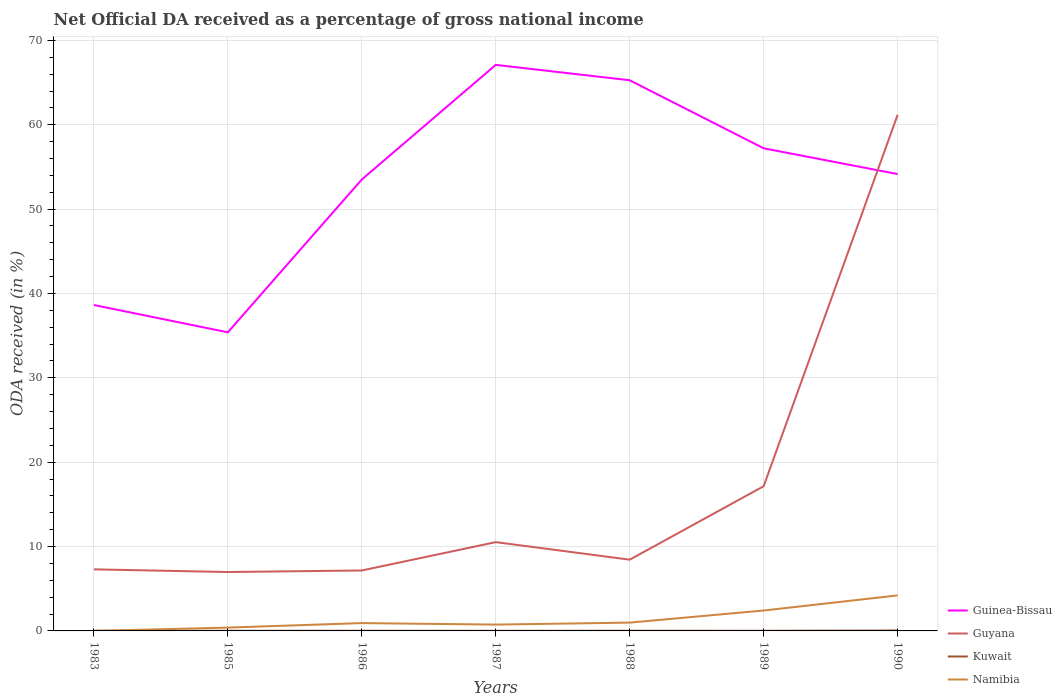Is the number of lines equal to the number of legend labels?
Offer a very short reply. Yes. Across all years, what is the maximum net official DA received in Guinea-Bissau?
Your response must be concise. 35.4. What is the total net official DA received in Namibia in the graph?
Your response must be concise. -3.46. What is the difference between the highest and the second highest net official DA received in Namibia?
Provide a succinct answer. 4.21. What is the difference between the highest and the lowest net official DA received in Kuwait?
Your answer should be compact. 1. What is the difference between two consecutive major ticks on the Y-axis?
Your answer should be compact. 10. Does the graph contain any zero values?
Offer a very short reply. No. Does the graph contain grids?
Give a very brief answer. Yes. How many legend labels are there?
Offer a very short reply. 4. How are the legend labels stacked?
Ensure brevity in your answer.  Vertical. What is the title of the graph?
Make the answer very short. Net Official DA received as a percentage of gross national income. Does "Finland" appear as one of the legend labels in the graph?
Your answer should be compact. No. What is the label or title of the Y-axis?
Make the answer very short. ODA received (in %). What is the ODA received (in %) in Guinea-Bissau in 1983?
Give a very brief answer. 38.63. What is the ODA received (in %) of Guyana in 1983?
Provide a succinct answer. 7.3. What is the ODA received (in %) of Kuwait in 1983?
Give a very brief answer. 0.02. What is the ODA received (in %) of Namibia in 1983?
Make the answer very short. 0. What is the ODA received (in %) in Guinea-Bissau in 1985?
Provide a short and direct response. 35.4. What is the ODA received (in %) in Guyana in 1985?
Provide a short and direct response. 6.98. What is the ODA received (in %) of Kuwait in 1985?
Offer a terse response. 0.02. What is the ODA received (in %) in Namibia in 1985?
Make the answer very short. 0.4. What is the ODA received (in %) of Guinea-Bissau in 1986?
Give a very brief answer. 53.51. What is the ODA received (in %) of Guyana in 1986?
Provide a succinct answer. 7.17. What is the ODA received (in %) in Kuwait in 1986?
Offer a very short reply. 0.02. What is the ODA received (in %) of Namibia in 1986?
Provide a succinct answer. 0.93. What is the ODA received (in %) of Guinea-Bissau in 1987?
Offer a terse response. 67.1. What is the ODA received (in %) in Guyana in 1987?
Keep it short and to the point. 10.52. What is the ODA received (in %) of Kuwait in 1987?
Offer a terse response. 0.01. What is the ODA received (in %) in Namibia in 1987?
Offer a terse response. 0.75. What is the ODA received (in %) of Guinea-Bissau in 1988?
Provide a succinct answer. 65.27. What is the ODA received (in %) in Guyana in 1988?
Make the answer very short. 8.45. What is the ODA received (in %) in Kuwait in 1988?
Give a very brief answer. 0.02. What is the ODA received (in %) of Namibia in 1988?
Provide a short and direct response. 0.99. What is the ODA received (in %) of Guinea-Bissau in 1989?
Offer a terse response. 57.21. What is the ODA received (in %) in Guyana in 1989?
Give a very brief answer. 17.15. What is the ODA received (in %) of Kuwait in 1989?
Offer a terse response. 0.01. What is the ODA received (in %) of Namibia in 1989?
Your answer should be compact. 2.42. What is the ODA received (in %) in Guinea-Bissau in 1990?
Give a very brief answer. 54.15. What is the ODA received (in %) of Guyana in 1990?
Your answer should be very brief. 61.17. What is the ODA received (in %) in Kuwait in 1990?
Your answer should be very brief. 0.05. What is the ODA received (in %) in Namibia in 1990?
Provide a succinct answer. 4.21. Across all years, what is the maximum ODA received (in %) of Guinea-Bissau?
Keep it short and to the point. 67.1. Across all years, what is the maximum ODA received (in %) of Guyana?
Your answer should be compact. 61.17. Across all years, what is the maximum ODA received (in %) in Kuwait?
Make the answer very short. 0.05. Across all years, what is the maximum ODA received (in %) in Namibia?
Give a very brief answer. 4.21. Across all years, what is the minimum ODA received (in %) in Guinea-Bissau?
Keep it short and to the point. 35.4. Across all years, what is the minimum ODA received (in %) in Guyana?
Make the answer very short. 6.98. Across all years, what is the minimum ODA received (in %) of Kuwait?
Make the answer very short. 0.01. Across all years, what is the minimum ODA received (in %) of Namibia?
Keep it short and to the point. 0. What is the total ODA received (in %) in Guinea-Bissau in the graph?
Provide a succinct answer. 371.27. What is the total ODA received (in %) in Guyana in the graph?
Ensure brevity in your answer.  118.74. What is the total ODA received (in %) of Kuwait in the graph?
Provide a short and direct response. 0.15. What is the total ODA received (in %) of Namibia in the graph?
Your response must be concise. 9.69. What is the difference between the ODA received (in %) in Guinea-Bissau in 1983 and that in 1985?
Offer a very short reply. 3.23. What is the difference between the ODA received (in %) in Guyana in 1983 and that in 1985?
Make the answer very short. 0.32. What is the difference between the ODA received (in %) of Kuwait in 1983 and that in 1985?
Keep it short and to the point. 0. What is the difference between the ODA received (in %) in Namibia in 1983 and that in 1985?
Provide a succinct answer. -0.39. What is the difference between the ODA received (in %) of Guinea-Bissau in 1983 and that in 1986?
Offer a very short reply. -14.88. What is the difference between the ODA received (in %) of Guyana in 1983 and that in 1986?
Make the answer very short. 0.13. What is the difference between the ODA received (in %) of Namibia in 1983 and that in 1986?
Ensure brevity in your answer.  -0.93. What is the difference between the ODA received (in %) in Guinea-Bissau in 1983 and that in 1987?
Offer a very short reply. -28.47. What is the difference between the ODA received (in %) of Guyana in 1983 and that in 1987?
Your answer should be compact. -3.23. What is the difference between the ODA received (in %) of Kuwait in 1983 and that in 1987?
Offer a very short reply. 0.01. What is the difference between the ODA received (in %) of Namibia in 1983 and that in 1987?
Your response must be concise. -0.75. What is the difference between the ODA received (in %) in Guinea-Bissau in 1983 and that in 1988?
Give a very brief answer. -26.64. What is the difference between the ODA received (in %) of Guyana in 1983 and that in 1988?
Give a very brief answer. -1.15. What is the difference between the ODA received (in %) in Kuwait in 1983 and that in 1988?
Ensure brevity in your answer.  -0. What is the difference between the ODA received (in %) in Namibia in 1983 and that in 1988?
Ensure brevity in your answer.  -0.98. What is the difference between the ODA received (in %) in Guinea-Bissau in 1983 and that in 1989?
Offer a very short reply. -18.58. What is the difference between the ODA received (in %) of Guyana in 1983 and that in 1989?
Provide a short and direct response. -9.85. What is the difference between the ODA received (in %) in Kuwait in 1983 and that in 1989?
Offer a terse response. 0.01. What is the difference between the ODA received (in %) in Namibia in 1983 and that in 1989?
Provide a succinct answer. -2.42. What is the difference between the ODA received (in %) in Guinea-Bissau in 1983 and that in 1990?
Offer a terse response. -15.52. What is the difference between the ODA received (in %) of Guyana in 1983 and that in 1990?
Offer a very short reply. -53.87. What is the difference between the ODA received (in %) of Kuwait in 1983 and that in 1990?
Your response must be concise. -0.03. What is the difference between the ODA received (in %) of Namibia in 1983 and that in 1990?
Ensure brevity in your answer.  -4.21. What is the difference between the ODA received (in %) in Guinea-Bissau in 1985 and that in 1986?
Provide a succinct answer. -18.12. What is the difference between the ODA received (in %) in Guyana in 1985 and that in 1986?
Your answer should be compact. -0.18. What is the difference between the ODA received (in %) of Kuwait in 1985 and that in 1986?
Your answer should be compact. -0. What is the difference between the ODA received (in %) of Namibia in 1985 and that in 1986?
Offer a terse response. -0.53. What is the difference between the ODA received (in %) in Guinea-Bissau in 1985 and that in 1987?
Make the answer very short. -31.7. What is the difference between the ODA received (in %) of Guyana in 1985 and that in 1987?
Ensure brevity in your answer.  -3.54. What is the difference between the ODA received (in %) of Kuwait in 1985 and that in 1987?
Your answer should be very brief. 0. What is the difference between the ODA received (in %) of Namibia in 1985 and that in 1987?
Provide a succinct answer. -0.35. What is the difference between the ODA received (in %) in Guinea-Bissau in 1985 and that in 1988?
Keep it short and to the point. -29.88. What is the difference between the ODA received (in %) of Guyana in 1985 and that in 1988?
Your response must be concise. -1.46. What is the difference between the ODA received (in %) in Kuwait in 1985 and that in 1988?
Make the answer very short. -0.01. What is the difference between the ODA received (in %) in Namibia in 1985 and that in 1988?
Your answer should be very brief. -0.59. What is the difference between the ODA received (in %) of Guinea-Bissau in 1985 and that in 1989?
Your answer should be compact. -21.81. What is the difference between the ODA received (in %) of Guyana in 1985 and that in 1989?
Give a very brief answer. -10.17. What is the difference between the ODA received (in %) in Kuwait in 1985 and that in 1989?
Keep it short and to the point. 0. What is the difference between the ODA received (in %) of Namibia in 1985 and that in 1989?
Give a very brief answer. -2.02. What is the difference between the ODA received (in %) in Guinea-Bissau in 1985 and that in 1990?
Your answer should be very brief. -18.76. What is the difference between the ODA received (in %) in Guyana in 1985 and that in 1990?
Offer a very short reply. -54.19. What is the difference between the ODA received (in %) of Kuwait in 1985 and that in 1990?
Your response must be concise. -0.03. What is the difference between the ODA received (in %) of Namibia in 1985 and that in 1990?
Give a very brief answer. -3.81. What is the difference between the ODA received (in %) in Guinea-Bissau in 1986 and that in 1987?
Ensure brevity in your answer.  -13.58. What is the difference between the ODA received (in %) of Guyana in 1986 and that in 1987?
Your response must be concise. -3.36. What is the difference between the ODA received (in %) in Kuwait in 1986 and that in 1987?
Provide a succinct answer. 0.01. What is the difference between the ODA received (in %) in Namibia in 1986 and that in 1987?
Make the answer very short. 0.18. What is the difference between the ODA received (in %) in Guinea-Bissau in 1986 and that in 1988?
Your response must be concise. -11.76. What is the difference between the ODA received (in %) in Guyana in 1986 and that in 1988?
Give a very brief answer. -1.28. What is the difference between the ODA received (in %) of Kuwait in 1986 and that in 1988?
Provide a succinct answer. -0. What is the difference between the ODA received (in %) of Namibia in 1986 and that in 1988?
Your answer should be compact. -0.06. What is the difference between the ODA received (in %) of Guinea-Bissau in 1986 and that in 1989?
Give a very brief answer. -3.7. What is the difference between the ODA received (in %) of Guyana in 1986 and that in 1989?
Make the answer very short. -9.99. What is the difference between the ODA received (in %) of Kuwait in 1986 and that in 1989?
Your answer should be compact. 0. What is the difference between the ODA received (in %) in Namibia in 1986 and that in 1989?
Make the answer very short. -1.49. What is the difference between the ODA received (in %) in Guinea-Bissau in 1986 and that in 1990?
Your response must be concise. -0.64. What is the difference between the ODA received (in %) of Guyana in 1986 and that in 1990?
Keep it short and to the point. -54.01. What is the difference between the ODA received (in %) of Kuwait in 1986 and that in 1990?
Offer a very short reply. -0.03. What is the difference between the ODA received (in %) of Namibia in 1986 and that in 1990?
Your answer should be compact. -3.28. What is the difference between the ODA received (in %) of Guinea-Bissau in 1987 and that in 1988?
Make the answer very short. 1.82. What is the difference between the ODA received (in %) in Guyana in 1987 and that in 1988?
Keep it short and to the point. 2.08. What is the difference between the ODA received (in %) in Kuwait in 1987 and that in 1988?
Keep it short and to the point. -0.01. What is the difference between the ODA received (in %) of Namibia in 1987 and that in 1988?
Ensure brevity in your answer.  -0.24. What is the difference between the ODA received (in %) of Guinea-Bissau in 1987 and that in 1989?
Offer a terse response. 9.89. What is the difference between the ODA received (in %) of Guyana in 1987 and that in 1989?
Offer a terse response. -6.63. What is the difference between the ODA received (in %) of Kuwait in 1987 and that in 1989?
Offer a very short reply. -0. What is the difference between the ODA received (in %) of Namibia in 1987 and that in 1989?
Provide a succinct answer. -1.67. What is the difference between the ODA received (in %) of Guinea-Bissau in 1987 and that in 1990?
Your answer should be compact. 12.94. What is the difference between the ODA received (in %) in Guyana in 1987 and that in 1990?
Offer a very short reply. -50.65. What is the difference between the ODA received (in %) in Kuwait in 1987 and that in 1990?
Give a very brief answer. -0.04. What is the difference between the ODA received (in %) of Namibia in 1987 and that in 1990?
Your answer should be compact. -3.46. What is the difference between the ODA received (in %) in Guinea-Bissau in 1988 and that in 1989?
Provide a succinct answer. 8.06. What is the difference between the ODA received (in %) of Guyana in 1988 and that in 1989?
Your answer should be very brief. -8.71. What is the difference between the ODA received (in %) in Kuwait in 1988 and that in 1989?
Your answer should be compact. 0.01. What is the difference between the ODA received (in %) in Namibia in 1988 and that in 1989?
Your answer should be very brief. -1.43. What is the difference between the ODA received (in %) of Guinea-Bissau in 1988 and that in 1990?
Ensure brevity in your answer.  11.12. What is the difference between the ODA received (in %) in Guyana in 1988 and that in 1990?
Provide a succinct answer. -52.73. What is the difference between the ODA received (in %) of Kuwait in 1988 and that in 1990?
Give a very brief answer. -0.03. What is the difference between the ODA received (in %) of Namibia in 1988 and that in 1990?
Provide a succinct answer. -3.22. What is the difference between the ODA received (in %) of Guinea-Bissau in 1989 and that in 1990?
Your answer should be compact. 3.06. What is the difference between the ODA received (in %) of Guyana in 1989 and that in 1990?
Provide a succinct answer. -44.02. What is the difference between the ODA received (in %) in Kuwait in 1989 and that in 1990?
Give a very brief answer. -0.04. What is the difference between the ODA received (in %) in Namibia in 1989 and that in 1990?
Provide a succinct answer. -1.79. What is the difference between the ODA received (in %) of Guinea-Bissau in 1983 and the ODA received (in %) of Guyana in 1985?
Ensure brevity in your answer.  31.65. What is the difference between the ODA received (in %) in Guinea-Bissau in 1983 and the ODA received (in %) in Kuwait in 1985?
Provide a short and direct response. 38.61. What is the difference between the ODA received (in %) of Guinea-Bissau in 1983 and the ODA received (in %) of Namibia in 1985?
Offer a terse response. 38.24. What is the difference between the ODA received (in %) of Guyana in 1983 and the ODA received (in %) of Kuwait in 1985?
Give a very brief answer. 7.28. What is the difference between the ODA received (in %) in Guyana in 1983 and the ODA received (in %) in Namibia in 1985?
Offer a terse response. 6.9. What is the difference between the ODA received (in %) of Kuwait in 1983 and the ODA received (in %) of Namibia in 1985?
Your response must be concise. -0.38. What is the difference between the ODA received (in %) of Guinea-Bissau in 1983 and the ODA received (in %) of Guyana in 1986?
Keep it short and to the point. 31.47. What is the difference between the ODA received (in %) in Guinea-Bissau in 1983 and the ODA received (in %) in Kuwait in 1986?
Your answer should be compact. 38.61. What is the difference between the ODA received (in %) in Guinea-Bissau in 1983 and the ODA received (in %) in Namibia in 1986?
Offer a very short reply. 37.7. What is the difference between the ODA received (in %) of Guyana in 1983 and the ODA received (in %) of Kuwait in 1986?
Keep it short and to the point. 7.28. What is the difference between the ODA received (in %) in Guyana in 1983 and the ODA received (in %) in Namibia in 1986?
Offer a terse response. 6.37. What is the difference between the ODA received (in %) of Kuwait in 1983 and the ODA received (in %) of Namibia in 1986?
Make the answer very short. -0.91. What is the difference between the ODA received (in %) in Guinea-Bissau in 1983 and the ODA received (in %) in Guyana in 1987?
Make the answer very short. 28.11. What is the difference between the ODA received (in %) of Guinea-Bissau in 1983 and the ODA received (in %) of Kuwait in 1987?
Provide a short and direct response. 38.62. What is the difference between the ODA received (in %) in Guinea-Bissau in 1983 and the ODA received (in %) in Namibia in 1987?
Your answer should be compact. 37.88. What is the difference between the ODA received (in %) of Guyana in 1983 and the ODA received (in %) of Kuwait in 1987?
Keep it short and to the point. 7.29. What is the difference between the ODA received (in %) in Guyana in 1983 and the ODA received (in %) in Namibia in 1987?
Provide a short and direct response. 6.55. What is the difference between the ODA received (in %) of Kuwait in 1983 and the ODA received (in %) of Namibia in 1987?
Your answer should be compact. -0.73. What is the difference between the ODA received (in %) in Guinea-Bissau in 1983 and the ODA received (in %) in Guyana in 1988?
Make the answer very short. 30.18. What is the difference between the ODA received (in %) of Guinea-Bissau in 1983 and the ODA received (in %) of Kuwait in 1988?
Your response must be concise. 38.61. What is the difference between the ODA received (in %) of Guinea-Bissau in 1983 and the ODA received (in %) of Namibia in 1988?
Offer a terse response. 37.65. What is the difference between the ODA received (in %) of Guyana in 1983 and the ODA received (in %) of Kuwait in 1988?
Give a very brief answer. 7.28. What is the difference between the ODA received (in %) of Guyana in 1983 and the ODA received (in %) of Namibia in 1988?
Offer a very short reply. 6.31. What is the difference between the ODA received (in %) of Kuwait in 1983 and the ODA received (in %) of Namibia in 1988?
Provide a succinct answer. -0.97. What is the difference between the ODA received (in %) of Guinea-Bissau in 1983 and the ODA received (in %) of Guyana in 1989?
Make the answer very short. 21.48. What is the difference between the ODA received (in %) of Guinea-Bissau in 1983 and the ODA received (in %) of Kuwait in 1989?
Offer a very short reply. 38.62. What is the difference between the ODA received (in %) of Guinea-Bissau in 1983 and the ODA received (in %) of Namibia in 1989?
Make the answer very short. 36.21. What is the difference between the ODA received (in %) in Guyana in 1983 and the ODA received (in %) in Kuwait in 1989?
Keep it short and to the point. 7.28. What is the difference between the ODA received (in %) in Guyana in 1983 and the ODA received (in %) in Namibia in 1989?
Give a very brief answer. 4.88. What is the difference between the ODA received (in %) in Kuwait in 1983 and the ODA received (in %) in Namibia in 1989?
Provide a short and direct response. -2.4. What is the difference between the ODA received (in %) of Guinea-Bissau in 1983 and the ODA received (in %) of Guyana in 1990?
Provide a succinct answer. -22.54. What is the difference between the ODA received (in %) in Guinea-Bissau in 1983 and the ODA received (in %) in Kuwait in 1990?
Provide a short and direct response. 38.58. What is the difference between the ODA received (in %) in Guinea-Bissau in 1983 and the ODA received (in %) in Namibia in 1990?
Give a very brief answer. 34.42. What is the difference between the ODA received (in %) of Guyana in 1983 and the ODA received (in %) of Kuwait in 1990?
Your response must be concise. 7.25. What is the difference between the ODA received (in %) in Guyana in 1983 and the ODA received (in %) in Namibia in 1990?
Make the answer very short. 3.09. What is the difference between the ODA received (in %) in Kuwait in 1983 and the ODA received (in %) in Namibia in 1990?
Keep it short and to the point. -4.19. What is the difference between the ODA received (in %) in Guinea-Bissau in 1985 and the ODA received (in %) in Guyana in 1986?
Make the answer very short. 28.23. What is the difference between the ODA received (in %) of Guinea-Bissau in 1985 and the ODA received (in %) of Kuwait in 1986?
Offer a terse response. 35.38. What is the difference between the ODA received (in %) of Guinea-Bissau in 1985 and the ODA received (in %) of Namibia in 1986?
Your answer should be compact. 34.47. What is the difference between the ODA received (in %) in Guyana in 1985 and the ODA received (in %) in Kuwait in 1986?
Your response must be concise. 6.96. What is the difference between the ODA received (in %) in Guyana in 1985 and the ODA received (in %) in Namibia in 1986?
Provide a short and direct response. 6.05. What is the difference between the ODA received (in %) in Kuwait in 1985 and the ODA received (in %) in Namibia in 1986?
Provide a short and direct response. -0.91. What is the difference between the ODA received (in %) of Guinea-Bissau in 1985 and the ODA received (in %) of Guyana in 1987?
Your answer should be very brief. 24.87. What is the difference between the ODA received (in %) in Guinea-Bissau in 1985 and the ODA received (in %) in Kuwait in 1987?
Your answer should be very brief. 35.39. What is the difference between the ODA received (in %) in Guinea-Bissau in 1985 and the ODA received (in %) in Namibia in 1987?
Make the answer very short. 34.65. What is the difference between the ODA received (in %) in Guyana in 1985 and the ODA received (in %) in Kuwait in 1987?
Provide a short and direct response. 6.97. What is the difference between the ODA received (in %) in Guyana in 1985 and the ODA received (in %) in Namibia in 1987?
Give a very brief answer. 6.23. What is the difference between the ODA received (in %) of Kuwait in 1985 and the ODA received (in %) of Namibia in 1987?
Make the answer very short. -0.73. What is the difference between the ODA received (in %) of Guinea-Bissau in 1985 and the ODA received (in %) of Guyana in 1988?
Your response must be concise. 26.95. What is the difference between the ODA received (in %) of Guinea-Bissau in 1985 and the ODA received (in %) of Kuwait in 1988?
Offer a very short reply. 35.38. What is the difference between the ODA received (in %) of Guinea-Bissau in 1985 and the ODA received (in %) of Namibia in 1988?
Your answer should be very brief. 34.41. What is the difference between the ODA received (in %) in Guyana in 1985 and the ODA received (in %) in Kuwait in 1988?
Keep it short and to the point. 6.96. What is the difference between the ODA received (in %) of Guyana in 1985 and the ODA received (in %) of Namibia in 1988?
Ensure brevity in your answer.  6. What is the difference between the ODA received (in %) of Kuwait in 1985 and the ODA received (in %) of Namibia in 1988?
Give a very brief answer. -0.97. What is the difference between the ODA received (in %) of Guinea-Bissau in 1985 and the ODA received (in %) of Guyana in 1989?
Offer a terse response. 18.24. What is the difference between the ODA received (in %) of Guinea-Bissau in 1985 and the ODA received (in %) of Kuwait in 1989?
Offer a terse response. 35.38. What is the difference between the ODA received (in %) in Guinea-Bissau in 1985 and the ODA received (in %) in Namibia in 1989?
Offer a terse response. 32.98. What is the difference between the ODA received (in %) in Guyana in 1985 and the ODA received (in %) in Kuwait in 1989?
Ensure brevity in your answer.  6.97. What is the difference between the ODA received (in %) of Guyana in 1985 and the ODA received (in %) of Namibia in 1989?
Provide a succinct answer. 4.56. What is the difference between the ODA received (in %) of Kuwait in 1985 and the ODA received (in %) of Namibia in 1989?
Make the answer very short. -2.4. What is the difference between the ODA received (in %) of Guinea-Bissau in 1985 and the ODA received (in %) of Guyana in 1990?
Your answer should be compact. -25.78. What is the difference between the ODA received (in %) in Guinea-Bissau in 1985 and the ODA received (in %) in Kuwait in 1990?
Provide a short and direct response. 35.35. What is the difference between the ODA received (in %) of Guinea-Bissau in 1985 and the ODA received (in %) of Namibia in 1990?
Provide a short and direct response. 31.19. What is the difference between the ODA received (in %) of Guyana in 1985 and the ODA received (in %) of Kuwait in 1990?
Your response must be concise. 6.93. What is the difference between the ODA received (in %) in Guyana in 1985 and the ODA received (in %) in Namibia in 1990?
Offer a very short reply. 2.77. What is the difference between the ODA received (in %) in Kuwait in 1985 and the ODA received (in %) in Namibia in 1990?
Ensure brevity in your answer.  -4.19. What is the difference between the ODA received (in %) in Guinea-Bissau in 1986 and the ODA received (in %) in Guyana in 1987?
Provide a succinct answer. 42.99. What is the difference between the ODA received (in %) of Guinea-Bissau in 1986 and the ODA received (in %) of Kuwait in 1987?
Keep it short and to the point. 53.5. What is the difference between the ODA received (in %) in Guinea-Bissau in 1986 and the ODA received (in %) in Namibia in 1987?
Make the answer very short. 52.76. What is the difference between the ODA received (in %) in Guyana in 1986 and the ODA received (in %) in Kuwait in 1987?
Provide a succinct answer. 7.15. What is the difference between the ODA received (in %) in Guyana in 1986 and the ODA received (in %) in Namibia in 1987?
Your answer should be very brief. 6.42. What is the difference between the ODA received (in %) of Kuwait in 1986 and the ODA received (in %) of Namibia in 1987?
Make the answer very short. -0.73. What is the difference between the ODA received (in %) in Guinea-Bissau in 1986 and the ODA received (in %) in Guyana in 1988?
Provide a succinct answer. 45.07. What is the difference between the ODA received (in %) of Guinea-Bissau in 1986 and the ODA received (in %) of Kuwait in 1988?
Your response must be concise. 53.49. What is the difference between the ODA received (in %) of Guinea-Bissau in 1986 and the ODA received (in %) of Namibia in 1988?
Your answer should be very brief. 52.53. What is the difference between the ODA received (in %) in Guyana in 1986 and the ODA received (in %) in Kuwait in 1988?
Ensure brevity in your answer.  7.14. What is the difference between the ODA received (in %) of Guyana in 1986 and the ODA received (in %) of Namibia in 1988?
Provide a short and direct response. 6.18. What is the difference between the ODA received (in %) of Kuwait in 1986 and the ODA received (in %) of Namibia in 1988?
Provide a succinct answer. -0.97. What is the difference between the ODA received (in %) of Guinea-Bissau in 1986 and the ODA received (in %) of Guyana in 1989?
Give a very brief answer. 36.36. What is the difference between the ODA received (in %) of Guinea-Bissau in 1986 and the ODA received (in %) of Kuwait in 1989?
Your response must be concise. 53.5. What is the difference between the ODA received (in %) of Guinea-Bissau in 1986 and the ODA received (in %) of Namibia in 1989?
Ensure brevity in your answer.  51.09. What is the difference between the ODA received (in %) of Guyana in 1986 and the ODA received (in %) of Kuwait in 1989?
Your answer should be compact. 7.15. What is the difference between the ODA received (in %) in Guyana in 1986 and the ODA received (in %) in Namibia in 1989?
Offer a terse response. 4.75. What is the difference between the ODA received (in %) of Kuwait in 1986 and the ODA received (in %) of Namibia in 1989?
Your answer should be very brief. -2.4. What is the difference between the ODA received (in %) of Guinea-Bissau in 1986 and the ODA received (in %) of Guyana in 1990?
Keep it short and to the point. -7.66. What is the difference between the ODA received (in %) in Guinea-Bissau in 1986 and the ODA received (in %) in Kuwait in 1990?
Offer a very short reply. 53.46. What is the difference between the ODA received (in %) in Guinea-Bissau in 1986 and the ODA received (in %) in Namibia in 1990?
Ensure brevity in your answer.  49.3. What is the difference between the ODA received (in %) of Guyana in 1986 and the ODA received (in %) of Kuwait in 1990?
Provide a succinct answer. 7.12. What is the difference between the ODA received (in %) of Guyana in 1986 and the ODA received (in %) of Namibia in 1990?
Your answer should be compact. 2.96. What is the difference between the ODA received (in %) of Kuwait in 1986 and the ODA received (in %) of Namibia in 1990?
Make the answer very short. -4.19. What is the difference between the ODA received (in %) in Guinea-Bissau in 1987 and the ODA received (in %) in Guyana in 1988?
Ensure brevity in your answer.  58.65. What is the difference between the ODA received (in %) of Guinea-Bissau in 1987 and the ODA received (in %) of Kuwait in 1988?
Your response must be concise. 67.08. What is the difference between the ODA received (in %) of Guinea-Bissau in 1987 and the ODA received (in %) of Namibia in 1988?
Ensure brevity in your answer.  66.11. What is the difference between the ODA received (in %) of Guyana in 1987 and the ODA received (in %) of Kuwait in 1988?
Give a very brief answer. 10.5. What is the difference between the ODA received (in %) of Guyana in 1987 and the ODA received (in %) of Namibia in 1988?
Provide a short and direct response. 9.54. What is the difference between the ODA received (in %) of Kuwait in 1987 and the ODA received (in %) of Namibia in 1988?
Keep it short and to the point. -0.97. What is the difference between the ODA received (in %) in Guinea-Bissau in 1987 and the ODA received (in %) in Guyana in 1989?
Ensure brevity in your answer.  49.94. What is the difference between the ODA received (in %) in Guinea-Bissau in 1987 and the ODA received (in %) in Kuwait in 1989?
Offer a very short reply. 67.08. What is the difference between the ODA received (in %) of Guinea-Bissau in 1987 and the ODA received (in %) of Namibia in 1989?
Your response must be concise. 64.68. What is the difference between the ODA received (in %) in Guyana in 1987 and the ODA received (in %) in Kuwait in 1989?
Provide a short and direct response. 10.51. What is the difference between the ODA received (in %) in Guyana in 1987 and the ODA received (in %) in Namibia in 1989?
Your answer should be compact. 8.1. What is the difference between the ODA received (in %) in Kuwait in 1987 and the ODA received (in %) in Namibia in 1989?
Your answer should be very brief. -2.41. What is the difference between the ODA received (in %) in Guinea-Bissau in 1987 and the ODA received (in %) in Guyana in 1990?
Give a very brief answer. 5.92. What is the difference between the ODA received (in %) of Guinea-Bissau in 1987 and the ODA received (in %) of Kuwait in 1990?
Offer a terse response. 67.05. What is the difference between the ODA received (in %) of Guinea-Bissau in 1987 and the ODA received (in %) of Namibia in 1990?
Keep it short and to the point. 62.89. What is the difference between the ODA received (in %) in Guyana in 1987 and the ODA received (in %) in Kuwait in 1990?
Offer a terse response. 10.47. What is the difference between the ODA received (in %) in Guyana in 1987 and the ODA received (in %) in Namibia in 1990?
Give a very brief answer. 6.31. What is the difference between the ODA received (in %) of Kuwait in 1987 and the ODA received (in %) of Namibia in 1990?
Keep it short and to the point. -4.2. What is the difference between the ODA received (in %) in Guinea-Bissau in 1988 and the ODA received (in %) in Guyana in 1989?
Give a very brief answer. 48.12. What is the difference between the ODA received (in %) in Guinea-Bissau in 1988 and the ODA received (in %) in Kuwait in 1989?
Offer a terse response. 65.26. What is the difference between the ODA received (in %) in Guinea-Bissau in 1988 and the ODA received (in %) in Namibia in 1989?
Give a very brief answer. 62.85. What is the difference between the ODA received (in %) in Guyana in 1988 and the ODA received (in %) in Kuwait in 1989?
Your response must be concise. 8.43. What is the difference between the ODA received (in %) in Guyana in 1988 and the ODA received (in %) in Namibia in 1989?
Offer a terse response. 6.03. What is the difference between the ODA received (in %) in Kuwait in 1988 and the ODA received (in %) in Namibia in 1989?
Keep it short and to the point. -2.4. What is the difference between the ODA received (in %) of Guinea-Bissau in 1988 and the ODA received (in %) of Guyana in 1990?
Provide a succinct answer. 4.1. What is the difference between the ODA received (in %) of Guinea-Bissau in 1988 and the ODA received (in %) of Kuwait in 1990?
Your answer should be very brief. 65.22. What is the difference between the ODA received (in %) of Guinea-Bissau in 1988 and the ODA received (in %) of Namibia in 1990?
Your response must be concise. 61.06. What is the difference between the ODA received (in %) of Guyana in 1988 and the ODA received (in %) of Kuwait in 1990?
Provide a succinct answer. 8.4. What is the difference between the ODA received (in %) in Guyana in 1988 and the ODA received (in %) in Namibia in 1990?
Give a very brief answer. 4.24. What is the difference between the ODA received (in %) in Kuwait in 1988 and the ODA received (in %) in Namibia in 1990?
Your answer should be very brief. -4.19. What is the difference between the ODA received (in %) in Guinea-Bissau in 1989 and the ODA received (in %) in Guyana in 1990?
Offer a terse response. -3.96. What is the difference between the ODA received (in %) in Guinea-Bissau in 1989 and the ODA received (in %) in Kuwait in 1990?
Offer a very short reply. 57.16. What is the difference between the ODA received (in %) of Guinea-Bissau in 1989 and the ODA received (in %) of Namibia in 1990?
Ensure brevity in your answer.  53. What is the difference between the ODA received (in %) in Guyana in 1989 and the ODA received (in %) in Kuwait in 1990?
Keep it short and to the point. 17.1. What is the difference between the ODA received (in %) of Guyana in 1989 and the ODA received (in %) of Namibia in 1990?
Keep it short and to the point. 12.94. What is the difference between the ODA received (in %) in Kuwait in 1989 and the ODA received (in %) in Namibia in 1990?
Your response must be concise. -4.19. What is the average ODA received (in %) of Guinea-Bissau per year?
Your response must be concise. 53.04. What is the average ODA received (in %) of Guyana per year?
Give a very brief answer. 16.96. What is the average ODA received (in %) in Kuwait per year?
Provide a short and direct response. 0.02. What is the average ODA received (in %) of Namibia per year?
Offer a terse response. 1.38. In the year 1983, what is the difference between the ODA received (in %) in Guinea-Bissau and ODA received (in %) in Guyana?
Give a very brief answer. 31.33. In the year 1983, what is the difference between the ODA received (in %) in Guinea-Bissau and ODA received (in %) in Kuwait?
Your answer should be very brief. 38.61. In the year 1983, what is the difference between the ODA received (in %) in Guinea-Bissau and ODA received (in %) in Namibia?
Your answer should be compact. 38.63. In the year 1983, what is the difference between the ODA received (in %) in Guyana and ODA received (in %) in Kuwait?
Offer a very short reply. 7.28. In the year 1983, what is the difference between the ODA received (in %) of Guyana and ODA received (in %) of Namibia?
Provide a succinct answer. 7.3. In the year 1983, what is the difference between the ODA received (in %) in Kuwait and ODA received (in %) in Namibia?
Your answer should be compact. 0.02. In the year 1985, what is the difference between the ODA received (in %) in Guinea-Bissau and ODA received (in %) in Guyana?
Give a very brief answer. 28.42. In the year 1985, what is the difference between the ODA received (in %) in Guinea-Bissau and ODA received (in %) in Kuwait?
Ensure brevity in your answer.  35.38. In the year 1985, what is the difference between the ODA received (in %) in Guinea-Bissau and ODA received (in %) in Namibia?
Offer a terse response. 35. In the year 1985, what is the difference between the ODA received (in %) in Guyana and ODA received (in %) in Kuwait?
Your answer should be compact. 6.97. In the year 1985, what is the difference between the ODA received (in %) in Guyana and ODA received (in %) in Namibia?
Offer a very short reply. 6.59. In the year 1985, what is the difference between the ODA received (in %) of Kuwait and ODA received (in %) of Namibia?
Offer a very short reply. -0.38. In the year 1986, what is the difference between the ODA received (in %) of Guinea-Bissau and ODA received (in %) of Guyana?
Your answer should be compact. 46.35. In the year 1986, what is the difference between the ODA received (in %) in Guinea-Bissau and ODA received (in %) in Kuwait?
Ensure brevity in your answer.  53.49. In the year 1986, what is the difference between the ODA received (in %) in Guinea-Bissau and ODA received (in %) in Namibia?
Keep it short and to the point. 52.58. In the year 1986, what is the difference between the ODA received (in %) of Guyana and ODA received (in %) of Kuwait?
Provide a succinct answer. 7.15. In the year 1986, what is the difference between the ODA received (in %) in Guyana and ODA received (in %) in Namibia?
Give a very brief answer. 6.24. In the year 1986, what is the difference between the ODA received (in %) of Kuwait and ODA received (in %) of Namibia?
Ensure brevity in your answer.  -0.91. In the year 1987, what is the difference between the ODA received (in %) of Guinea-Bissau and ODA received (in %) of Guyana?
Your answer should be compact. 56.57. In the year 1987, what is the difference between the ODA received (in %) in Guinea-Bissau and ODA received (in %) in Kuwait?
Your answer should be compact. 67.08. In the year 1987, what is the difference between the ODA received (in %) in Guinea-Bissau and ODA received (in %) in Namibia?
Your answer should be compact. 66.35. In the year 1987, what is the difference between the ODA received (in %) of Guyana and ODA received (in %) of Kuwait?
Your answer should be compact. 10.51. In the year 1987, what is the difference between the ODA received (in %) of Guyana and ODA received (in %) of Namibia?
Make the answer very short. 9.77. In the year 1987, what is the difference between the ODA received (in %) in Kuwait and ODA received (in %) in Namibia?
Provide a short and direct response. -0.74. In the year 1988, what is the difference between the ODA received (in %) of Guinea-Bissau and ODA received (in %) of Guyana?
Your answer should be very brief. 56.83. In the year 1988, what is the difference between the ODA received (in %) in Guinea-Bissau and ODA received (in %) in Kuwait?
Your answer should be very brief. 65.25. In the year 1988, what is the difference between the ODA received (in %) of Guinea-Bissau and ODA received (in %) of Namibia?
Make the answer very short. 64.29. In the year 1988, what is the difference between the ODA received (in %) of Guyana and ODA received (in %) of Kuwait?
Your response must be concise. 8.42. In the year 1988, what is the difference between the ODA received (in %) in Guyana and ODA received (in %) in Namibia?
Provide a succinct answer. 7.46. In the year 1988, what is the difference between the ODA received (in %) in Kuwait and ODA received (in %) in Namibia?
Provide a short and direct response. -0.96. In the year 1989, what is the difference between the ODA received (in %) in Guinea-Bissau and ODA received (in %) in Guyana?
Give a very brief answer. 40.06. In the year 1989, what is the difference between the ODA received (in %) in Guinea-Bissau and ODA received (in %) in Kuwait?
Provide a succinct answer. 57.19. In the year 1989, what is the difference between the ODA received (in %) in Guinea-Bissau and ODA received (in %) in Namibia?
Offer a terse response. 54.79. In the year 1989, what is the difference between the ODA received (in %) of Guyana and ODA received (in %) of Kuwait?
Your answer should be very brief. 17.14. In the year 1989, what is the difference between the ODA received (in %) in Guyana and ODA received (in %) in Namibia?
Offer a terse response. 14.73. In the year 1989, what is the difference between the ODA received (in %) in Kuwait and ODA received (in %) in Namibia?
Keep it short and to the point. -2.41. In the year 1990, what is the difference between the ODA received (in %) in Guinea-Bissau and ODA received (in %) in Guyana?
Offer a terse response. -7.02. In the year 1990, what is the difference between the ODA received (in %) in Guinea-Bissau and ODA received (in %) in Kuwait?
Offer a terse response. 54.1. In the year 1990, what is the difference between the ODA received (in %) in Guinea-Bissau and ODA received (in %) in Namibia?
Your response must be concise. 49.94. In the year 1990, what is the difference between the ODA received (in %) of Guyana and ODA received (in %) of Kuwait?
Offer a terse response. 61.12. In the year 1990, what is the difference between the ODA received (in %) of Guyana and ODA received (in %) of Namibia?
Your response must be concise. 56.96. In the year 1990, what is the difference between the ODA received (in %) in Kuwait and ODA received (in %) in Namibia?
Your answer should be compact. -4.16. What is the ratio of the ODA received (in %) of Guinea-Bissau in 1983 to that in 1985?
Your answer should be very brief. 1.09. What is the ratio of the ODA received (in %) in Guyana in 1983 to that in 1985?
Make the answer very short. 1.05. What is the ratio of the ODA received (in %) of Kuwait in 1983 to that in 1985?
Provide a succinct answer. 1.23. What is the ratio of the ODA received (in %) in Namibia in 1983 to that in 1985?
Keep it short and to the point. 0. What is the ratio of the ODA received (in %) in Guinea-Bissau in 1983 to that in 1986?
Make the answer very short. 0.72. What is the ratio of the ODA received (in %) in Guyana in 1983 to that in 1986?
Provide a succinct answer. 1.02. What is the ratio of the ODA received (in %) of Kuwait in 1983 to that in 1986?
Offer a terse response. 1.02. What is the ratio of the ODA received (in %) in Namibia in 1983 to that in 1986?
Provide a short and direct response. 0. What is the ratio of the ODA received (in %) of Guinea-Bissau in 1983 to that in 1987?
Your answer should be very brief. 0.58. What is the ratio of the ODA received (in %) in Guyana in 1983 to that in 1987?
Your answer should be very brief. 0.69. What is the ratio of the ODA received (in %) in Kuwait in 1983 to that in 1987?
Offer a very short reply. 1.63. What is the ratio of the ODA received (in %) of Namibia in 1983 to that in 1987?
Your answer should be very brief. 0. What is the ratio of the ODA received (in %) of Guinea-Bissau in 1983 to that in 1988?
Your response must be concise. 0.59. What is the ratio of the ODA received (in %) in Guyana in 1983 to that in 1988?
Make the answer very short. 0.86. What is the ratio of the ODA received (in %) of Kuwait in 1983 to that in 1988?
Your answer should be compact. 0.93. What is the ratio of the ODA received (in %) in Guinea-Bissau in 1983 to that in 1989?
Offer a very short reply. 0.68. What is the ratio of the ODA received (in %) of Guyana in 1983 to that in 1989?
Your answer should be very brief. 0.43. What is the ratio of the ODA received (in %) of Kuwait in 1983 to that in 1989?
Provide a succinct answer. 1.37. What is the ratio of the ODA received (in %) in Guinea-Bissau in 1983 to that in 1990?
Your answer should be compact. 0.71. What is the ratio of the ODA received (in %) of Guyana in 1983 to that in 1990?
Offer a terse response. 0.12. What is the ratio of the ODA received (in %) of Kuwait in 1983 to that in 1990?
Provide a succinct answer. 0.4. What is the ratio of the ODA received (in %) in Namibia in 1983 to that in 1990?
Offer a terse response. 0. What is the ratio of the ODA received (in %) of Guinea-Bissau in 1985 to that in 1986?
Make the answer very short. 0.66. What is the ratio of the ODA received (in %) in Guyana in 1985 to that in 1986?
Offer a very short reply. 0.97. What is the ratio of the ODA received (in %) of Kuwait in 1985 to that in 1986?
Make the answer very short. 0.83. What is the ratio of the ODA received (in %) in Namibia in 1985 to that in 1986?
Your answer should be very brief. 0.43. What is the ratio of the ODA received (in %) of Guinea-Bissau in 1985 to that in 1987?
Your response must be concise. 0.53. What is the ratio of the ODA received (in %) of Guyana in 1985 to that in 1987?
Your answer should be very brief. 0.66. What is the ratio of the ODA received (in %) in Kuwait in 1985 to that in 1987?
Offer a very short reply. 1.32. What is the ratio of the ODA received (in %) of Namibia in 1985 to that in 1987?
Give a very brief answer. 0.53. What is the ratio of the ODA received (in %) of Guinea-Bissau in 1985 to that in 1988?
Ensure brevity in your answer.  0.54. What is the ratio of the ODA received (in %) in Guyana in 1985 to that in 1988?
Ensure brevity in your answer.  0.83. What is the ratio of the ODA received (in %) in Kuwait in 1985 to that in 1988?
Your answer should be very brief. 0.75. What is the ratio of the ODA received (in %) in Namibia in 1985 to that in 1988?
Make the answer very short. 0.4. What is the ratio of the ODA received (in %) in Guinea-Bissau in 1985 to that in 1989?
Give a very brief answer. 0.62. What is the ratio of the ODA received (in %) in Guyana in 1985 to that in 1989?
Make the answer very short. 0.41. What is the ratio of the ODA received (in %) in Kuwait in 1985 to that in 1989?
Provide a succinct answer. 1.11. What is the ratio of the ODA received (in %) of Namibia in 1985 to that in 1989?
Provide a short and direct response. 0.16. What is the ratio of the ODA received (in %) in Guinea-Bissau in 1985 to that in 1990?
Offer a terse response. 0.65. What is the ratio of the ODA received (in %) of Guyana in 1985 to that in 1990?
Offer a terse response. 0.11. What is the ratio of the ODA received (in %) of Kuwait in 1985 to that in 1990?
Your answer should be very brief. 0.32. What is the ratio of the ODA received (in %) in Namibia in 1985 to that in 1990?
Give a very brief answer. 0.09. What is the ratio of the ODA received (in %) of Guinea-Bissau in 1986 to that in 1987?
Offer a very short reply. 0.8. What is the ratio of the ODA received (in %) in Guyana in 1986 to that in 1987?
Your answer should be very brief. 0.68. What is the ratio of the ODA received (in %) in Kuwait in 1986 to that in 1987?
Your answer should be compact. 1.6. What is the ratio of the ODA received (in %) of Namibia in 1986 to that in 1987?
Offer a terse response. 1.24. What is the ratio of the ODA received (in %) of Guinea-Bissau in 1986 to that in 1988?
Ensure brevity in your answer.  0.82. What is the ratio of the ODA received (in %) in Guyana in 1986 to that in 1988?
Give a very brief answer. 0.85. What is the ratio of the ODA received (in %) of Kuwait in 1986 to that in 1988?
Your response must be concise. 0.91. What is the ratio of the ODA received (in %) in Namibia in 1986 to that in 1988?
Provide a short and direct response. 0.94. What is the ratio of the ODA received (in %) of Guinea-Bissau in 1986 to that in 1989?
Provide a succinct answer. 0.94. What is the ratio of the ODA received (in %) in Guyana in 1986 to that in 1989?
Your answer should be very brief. 0.42. What is the ratio of the ODA received (in %) in Kuwait in 1986 to that in 1989?
Your answer should be compact. 1.34. What is the ratio of the ODA received (in %) in Namibia in 1986 to that in 1989?
Keep it short and to the point. 0.38. What is the ratio of the ODA received (in %) in Guyana in 1986 to that in 1990?
Your answer should be very brief. 0.12. What is the ratio of the ODA received (in %) of Kuwait in 1986 to that in 1990?
Provide a succinct answer. 0.39. What is the ratio of the ODA received (in %) of Namibia in 1986 to that in 1990?
Provide a succinct answer. 0.22. What is the ratio of the ODA received (in %) of Guinea-Bissau in 1987 to that in 1988?
Offer a very short reply. 1.03. What is the ratio of the ODA received (in %) in Guyana in 1987 to that in 1988?
Offer a very short reply. 1.25. What is the ratio of the ODA received (in %) of Kuwait in 1987 to that in 1988?
Give a very brief answer. 0.57. What is the ratio of the ODA received (in %) of Namibia in 1987 to that in 1988?
Your response must be concise. 0.76. What is the ratio of the ODA received (in %) in Guinea-Bissau in 1987 to that in 1989?
Provide a succinct answer. 1.17. What is the ratio of the ODA received (in %) of Guyana in 1987 to that in 1989?
Give a very brief answer. 0.61. What is the ratio of the ODA received (in %) of Kuwait in 1987 to that in 1989?
Offer a very short reply. 0.84. What is the ratio of the ODA received (in %) of Namibia in 1987 to that in 1989?
Make the answer very short. 0.31. What is the ratio of the ODA received (in %) of Guinea-Bissau in 1987 to that in 1990?
Provide a succinct answer. 1.24. What is the ratio of the ODA received (in %) in Guyana in 1987 to that in 1990?
Give a very brief answer. 0.17. What is the ratio of the ODA received (in %) in Kuwait in 1987 to that in 1990?
Offer a very short reply. 0.24. What is the ratio of the ODA received (in %) of Namibia in 1987 to that in 1990?
Your response must be concise. 0.18. What is the ratio of the ODA received (in %) of Guinea-Bissau in 1988 to that in 1989?
Ensure brevity in your answer.  1.14. What is the ratio of the ODA received (in %) of Guyana in 1988 to that in 1989?
Offer a terse response. 0.49. What is the ratio of the ODA received (in %) in Kuwait in 1988 to that in 1989?
Make the answer very short. 1.48. What is the ratio of the ODA received (in %) of Namibia in 1988 to that in 1989?
Your response must be concise. 0.41. What is the ratio of the ODA received (in %) in Guinea-Bissau in 1988 to that in 1990?
Ensure brevity in your answer.  1.21. What is the ratio of the ODA received (in %) of Guyana in 1988 to that in 1990?
Provide a short and direct response. 0.14. What is the ratio of the ODA received (in %) in Kuwait in 1988 to that in 1990?
Provide a short and direct response. 0.43. What is the ratio of the ODA received (in %) in Namibia in 1988 to that in 1990?
Give a very brief answer. 0.23. What is the ratio of the ODA received (in %) of Guinea-Bissau in 1989 to that in 1990?
Your answer should be compact. 1.06. What is the ratio of the ODA received (in %) of Guyana in 1989 to that in 1990?
Provide a short and direct response. 0.28. What is the ratio of the ODA received (in %) of Kuwait in 1989 to that in 1990?
Offer a terse response. 0.29. What is the ratio of the ODA received (in %) in Namibia in 1989 to that in 1990?
Your answer should be compact. 0.57. What is the difference between the highest and the second highest ODA received (in %) of Guinea-Bissau?
Make the answer very short. 1.82. What is the difference between the highest and the second highest ODA received (in %) of Guyana?
Keep it short and to the point. 44.02. What is the difference between the highest and the second highest ODA received (in %) in Kuwait?
Offer a very short reply. 0.03. What is the difference between the highest and the second highest ODA received (in %) in Namibia?
Provide a succinct answer. 1.79. What is the difference between the highest and the lowest ODA received (in %) in Guinea-Bissau?
Make the answer very short. 31.7. What is the difference between the highest and the lowest ODA received (in %) in Guyana?
Keep it short and to the point. 54.19. What is the difference between the highest and the lowest ODA received (in %) in Kuwait?
Provide a succinct answer. 0.04. What is the difference between the highest and the lowest ODA received (in %) in Namibia?
Offer a very short reply. 4.21. 